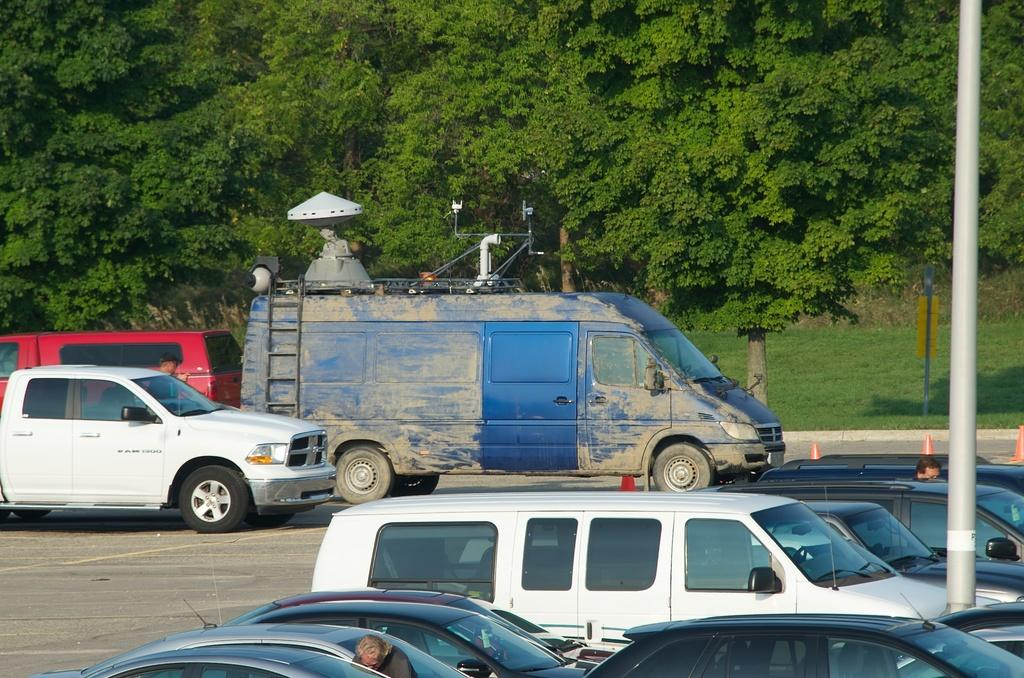What types of objects are at the bottom of the image? There are vehicles at the bottom of the image. Where is the pole located in the image? The pole is on the right side of the image. What can be seen in the background of the image? There are trees in the background of the image. Reasoning: Let'g: Let's think step by step in order to produce the conversation. We start by identifying the main subjects in the image, which are the vehicles and the pole. Then, we describe their locations within the image. Finally, we mention the background elements, which are the trees. Each question is designed to elicit a specific detail about the image that is known from the provided facts. Absurd Question/Answer: Can you tell me how many basketballs are on the pole in the image? A: There are no basketballs present in the image; the pole is not associated with any basketballs. What type of road is visible in the image? There is no road visible in the image; the focus is on the vehicles, pole, and trees. Can you tell me how many basketballs are on the pole in the image? There are no basketballs present in the image; the pole is not associated with any basketballs. What type of road is visible in the image? There is no road visible in the image; the focus is on the vehicles, pole, and trees. 